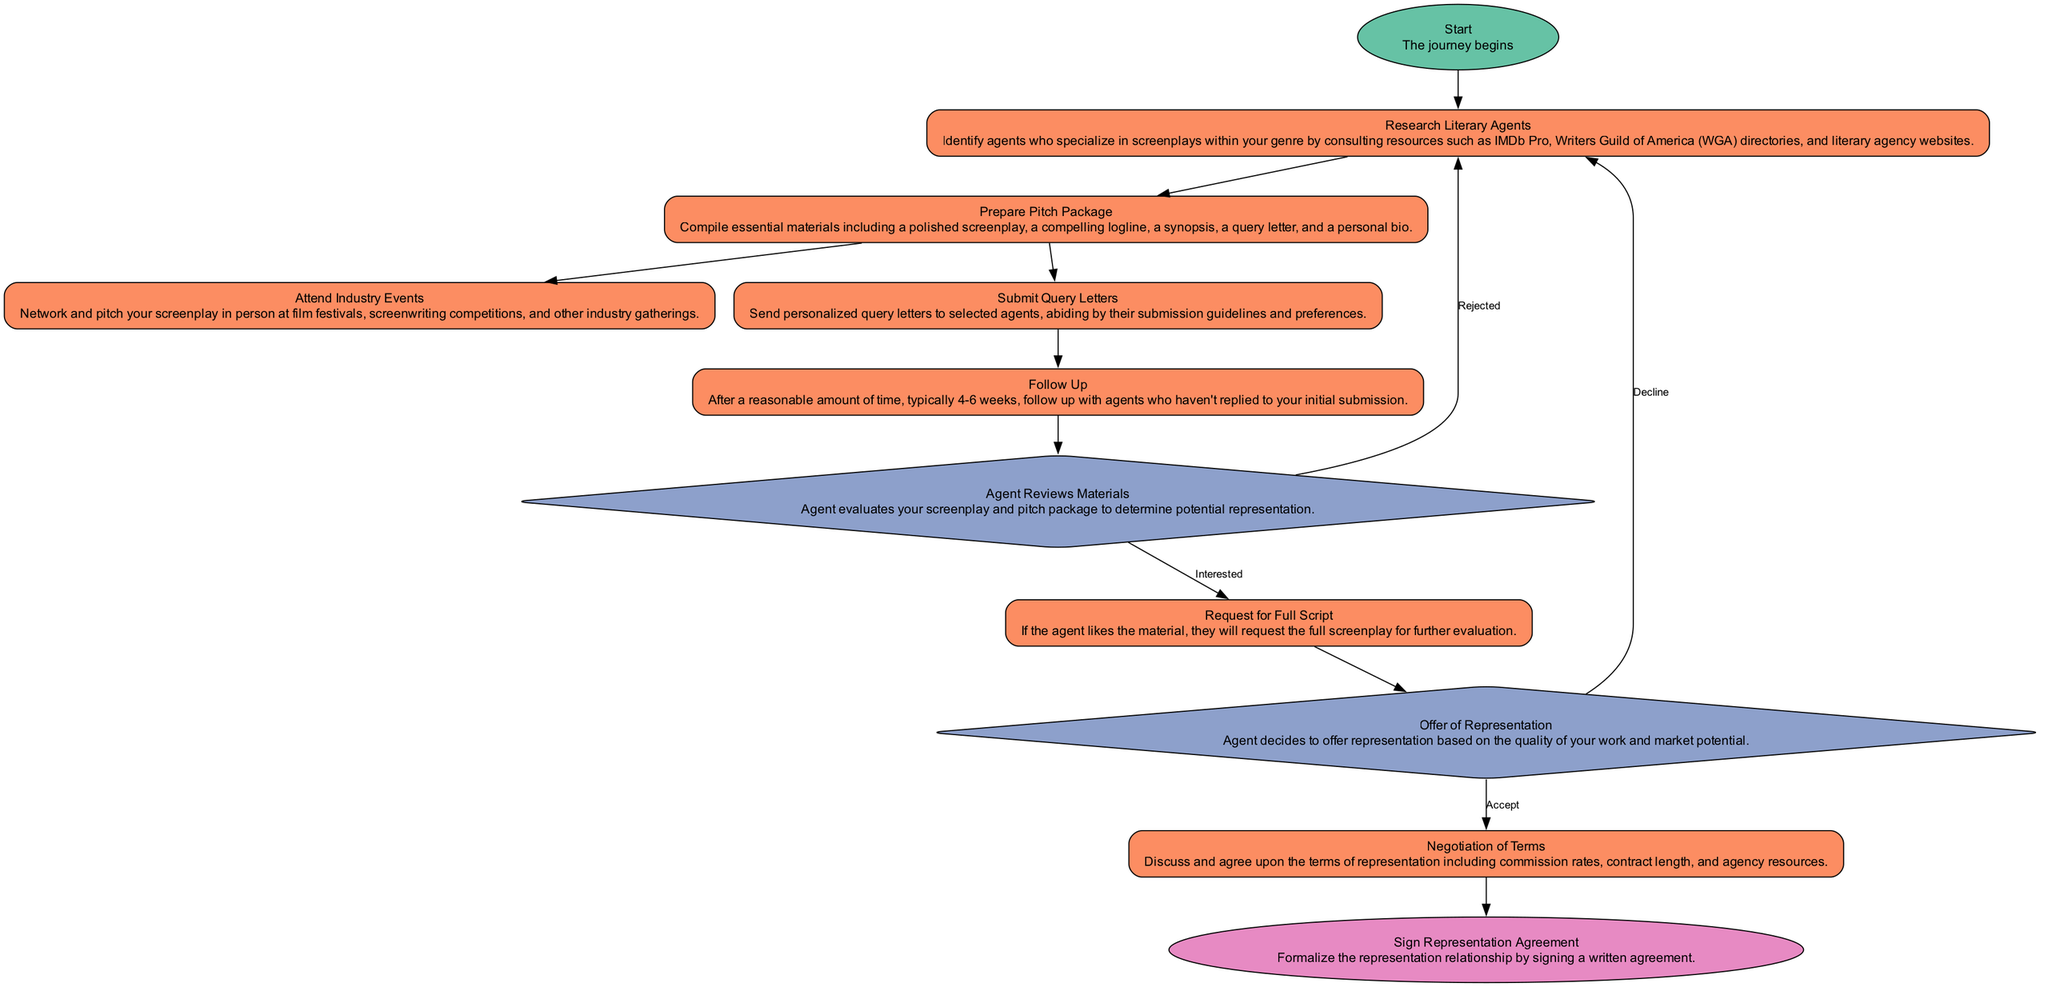What's the first step in securing a literary agent? The journey begins with the "Start" node, which indicates the initiation of the process for securing a literary agent. Thus, the first step to consider is to research literary agents.
Answer: Research Literary Agents How many process steps are in the diagram? To find the number of process steps, count all elements of type "process" in the diagram. They include "Research Literary Agents," "Prepare Pitch Package," "Attend Industry Events," "Submit Query Letters," "Follow Up," "Request for Full Script," and "Negotiation of Terms." Therefore, there are six process steps.
Answer: Six What follows after the agent reviews materials? After the agent reviews materials, if they are interested, the next step is the "Request for Full Script." This indicates that a positive evaluation leads to requesting further materials.
Answer: Request for Full Script Which node indicates a decision point in the process? The "Agent Reviews Materials" node indicates a decision point where the agent evaluates whether to proceed with representation or not. This step is pivotal as it determines the next actions based on their assessment.
Answer: Agent Reviews Materials What happens if the agent declines the offer of representation? If the agent declines the offer of representation, the diagram indicates that you return to "Research Literary Agents." This shows a loop back to the previous step to seek out new representation options.
Answer: Research Literary Agents What are the final steps after accepting an offer of representation? After accepting the offer of representation, the final steps are "Negotiation of Terms," followed by "Sign Representation Agreement." Thus, these steps culminate the process of achieving representation.
Answer: Negotiation of Terms, Sign Representation Agreement How many edges connect the "Submit Query Letters" node? The "Submit Query Letters" node has two outgoing edges. One leads to "Follow Up," and another connects to "Research Literary Agents" if the agent rejects it. Therefore, it connects twice in the flow.
Answer: Two What is the color representing a decision node? In the diagram, a decision node is represented with a color specified in the color palette as #8da0cb. This color is distinct to visually indicate decision points in the flow.
Answer: Blue 